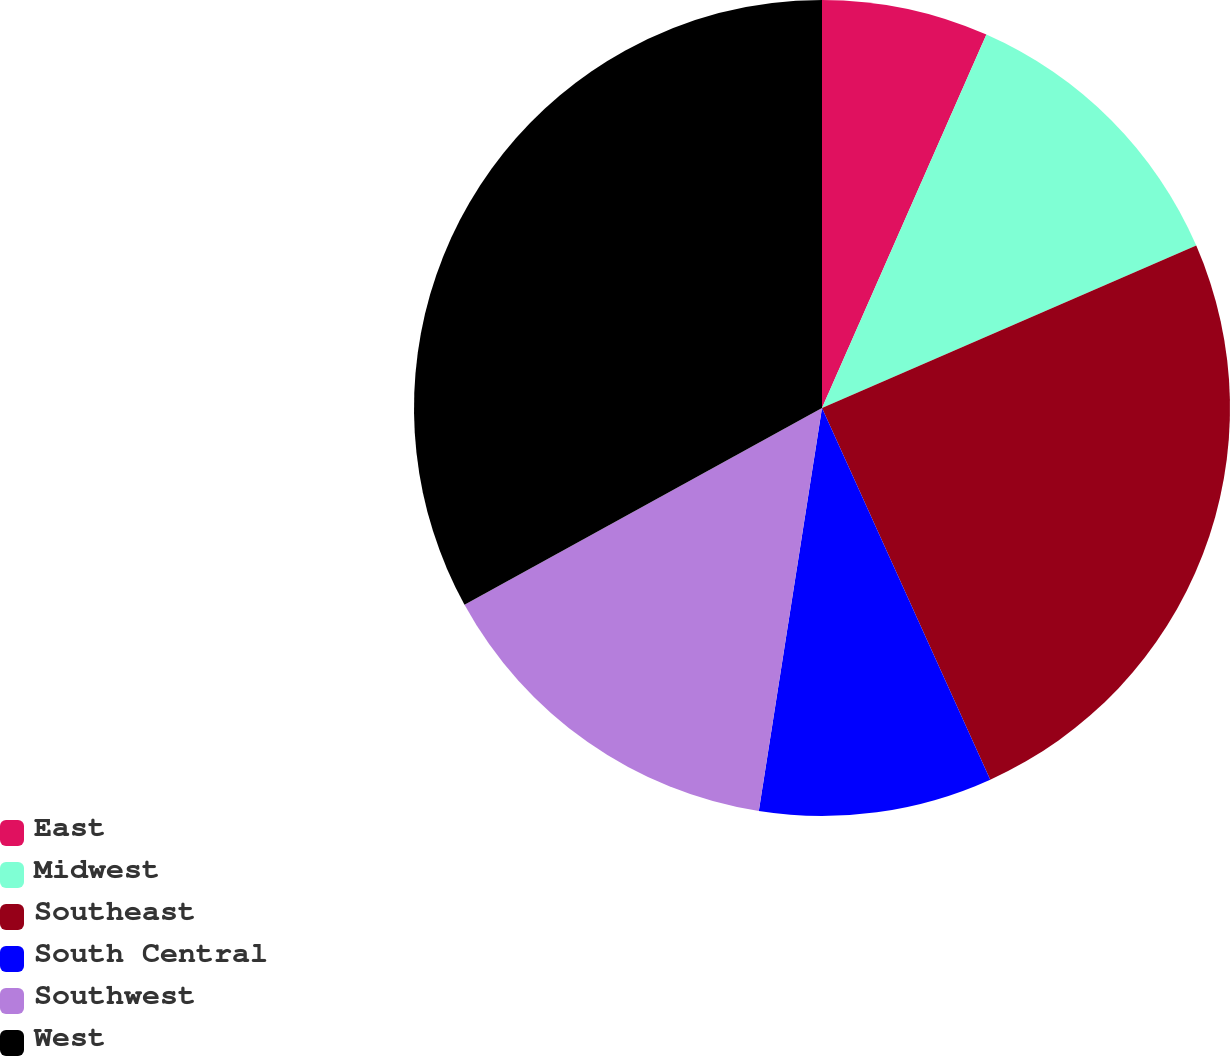Convert chart. <chart><loc_0><loc_0><loc_500><loc_500><pie_chart><fcel>East<fcel>Midwest<fcel>Southeast<fcel>South Central<fcel>Southwest<fcel>West<nl><fcel>6.6%<fcel>11.88%<fcel>24.75%<fcel>9.24%<fcel>14.52%<fcel>33.0%<nl></chart> 